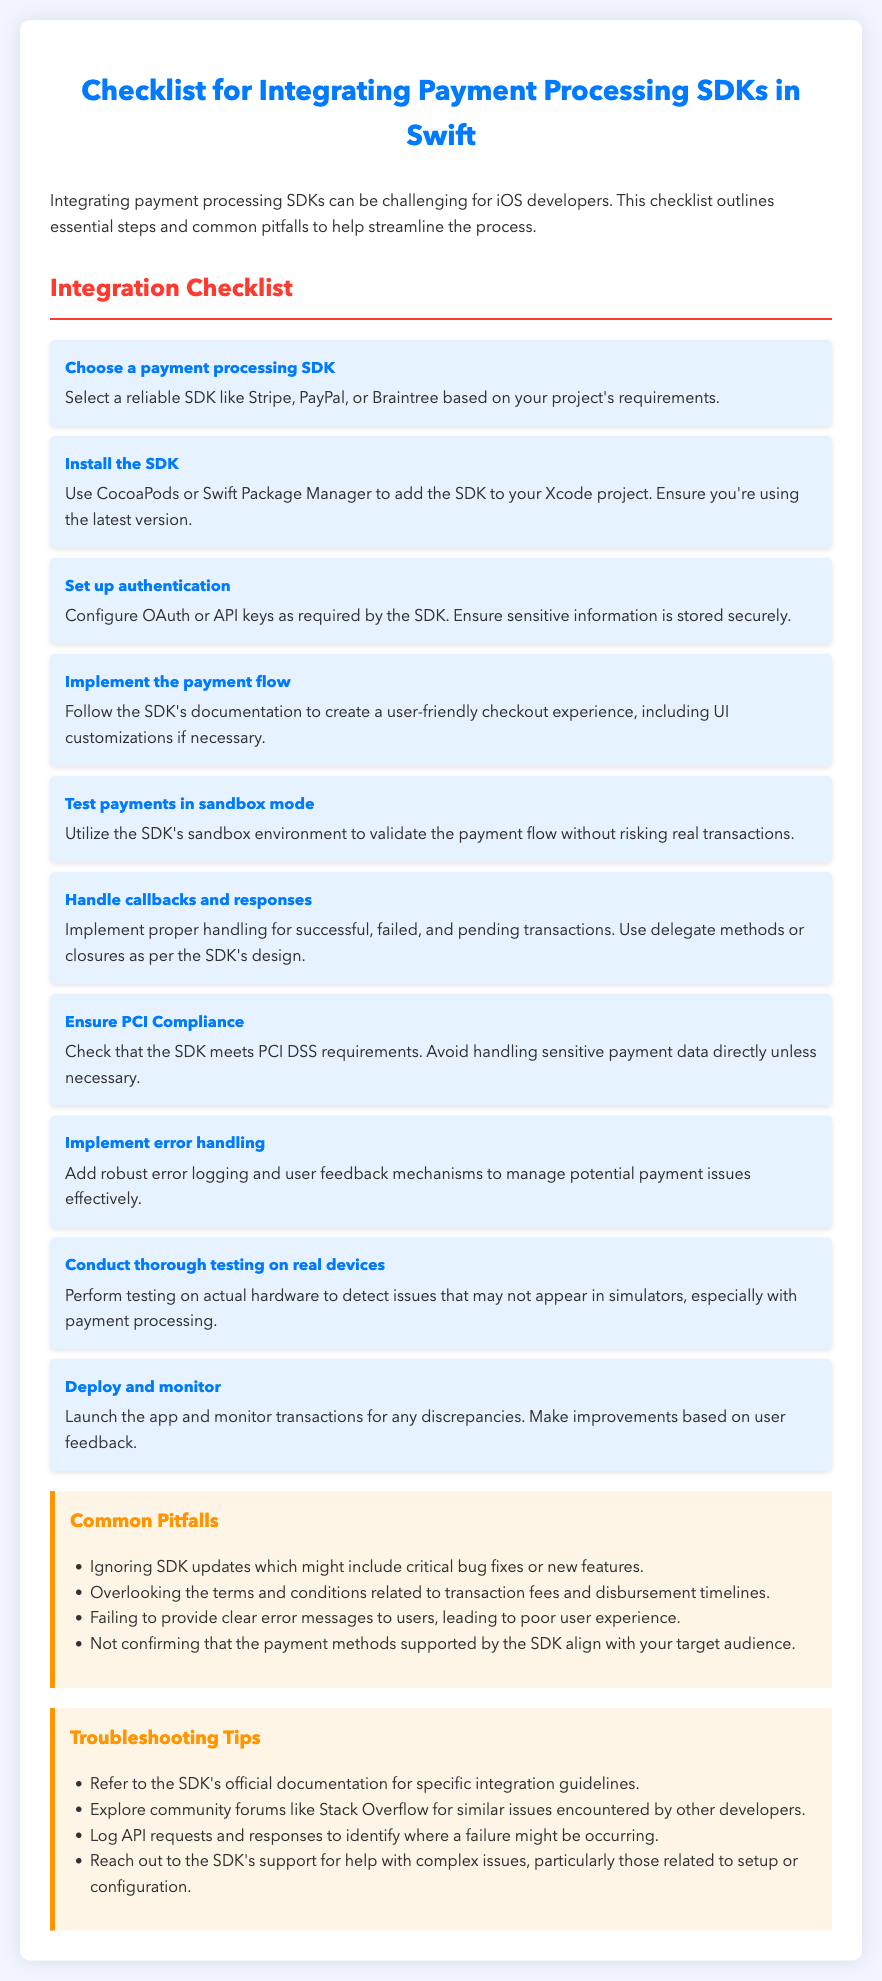What is the title of the document? The title is presented prominently at the top of the document, summarizing its content.
Answer: Checklist for Integrating Payment Processing SDKs in Swift How many steps are in the integration checklist? The checklist consists of a series of ordered steps, indicating the total number of items listed.
Answer: 10 Name one recommended payment processing SDK. The document suggests specific SDKs for use, highlighting options to choose from.
Answer: Stripe What should you do before deploying the app? The last item in the checklist outlines actions to take after app development but before launching it.
Answer: Monitor What is one common pitfall mentioned? The pitfalls section lists several issues to avoid during integration, describing potential errors.
Answer: Ignoring SDK updates What is one troubleshooting tip provided? The tips for troubleshooting give guidance on resolving integration issues, providing support avenues.
Answer: Refer to the SDK's official documentation What aspect should testers confirm before making a selection? The pitfalls section indicates necessary confirmations related to user accessibility and payment options.
Answer: Supported payment methods What type of compliance is emphasized in the integration checklist? The checklist includes essential requirements to ensure security in payment processing, specifically addressing regulatory standards.
Answer: PCI Compliance 